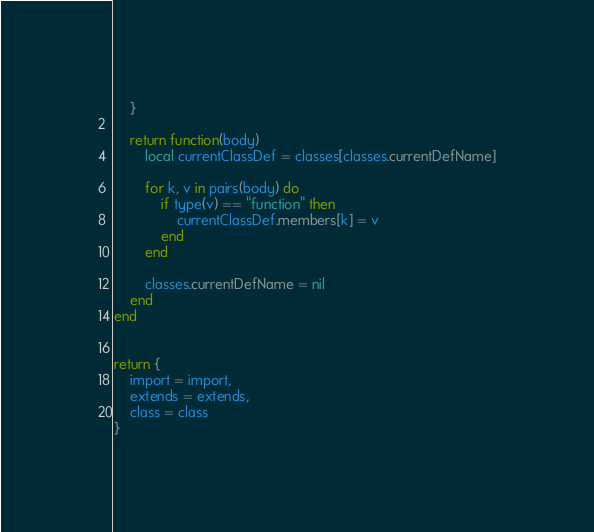Convert code to text. <code><loc_0><loc_0><loc_500><loc_500><_Lua_>	}

	return function(body)
		local currentClassDef = classes[classes.currentDefName]

		for k, v in pairs(body) do
			if type(v) == "function" then
				currentClassDef.members[k] = v
			end
		end

		classes.currentDefName = nil
	end
end


return {
	import = import,
	extends = extends,
	class = class
}
</code> 